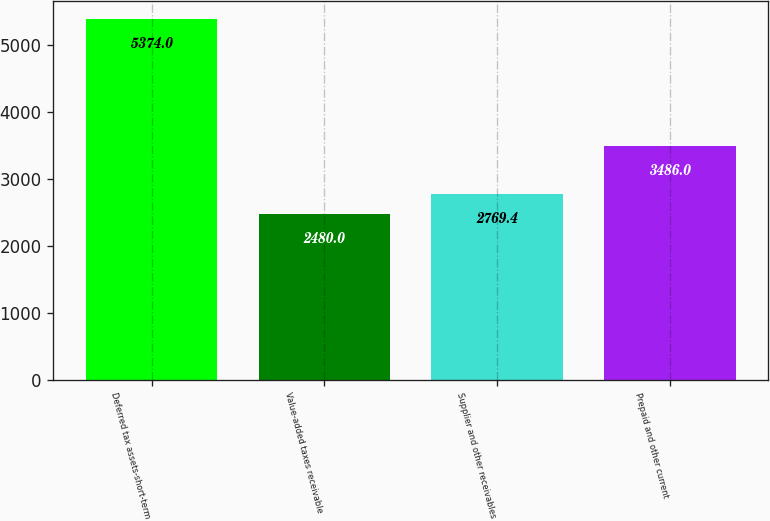Convert chart. <chart><loc_0><loc_0><loc_500><loc_500><bar_chart><fcel>Deferred tax assets-short-term<fcel>Value-added taxes receivable<fcel>Supplier and other receivables<fcel>Prepaid and other current<nl><fcel>5374<fcel>2480<fcel>2769.4<fcel>3486<nl></chart> 